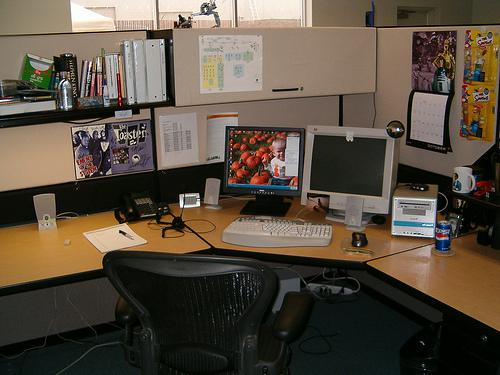Question: where are the pumpkins?
Choices:
A. In the patch.
B. At the store.
C. In the wooden bin.
D. Computer monitor.
Answer with the letter. Answer: D Question: what is in front of the desk?
Choices:
A. A student.
B. A wall.
C. Chair.
D. A window.
Answer with the letter. Answer: C Question: where are the computer monitors?
Choices:
A. At the store.
B. In the boxes.
C. Desk.
D. On the computer table.
Answer with the letter. Answer: C Question: what color is the chair?
Choices:
A. Brown.
B. Grey.
C. White.
D. Black.
Answer with the letter. Answer: D 